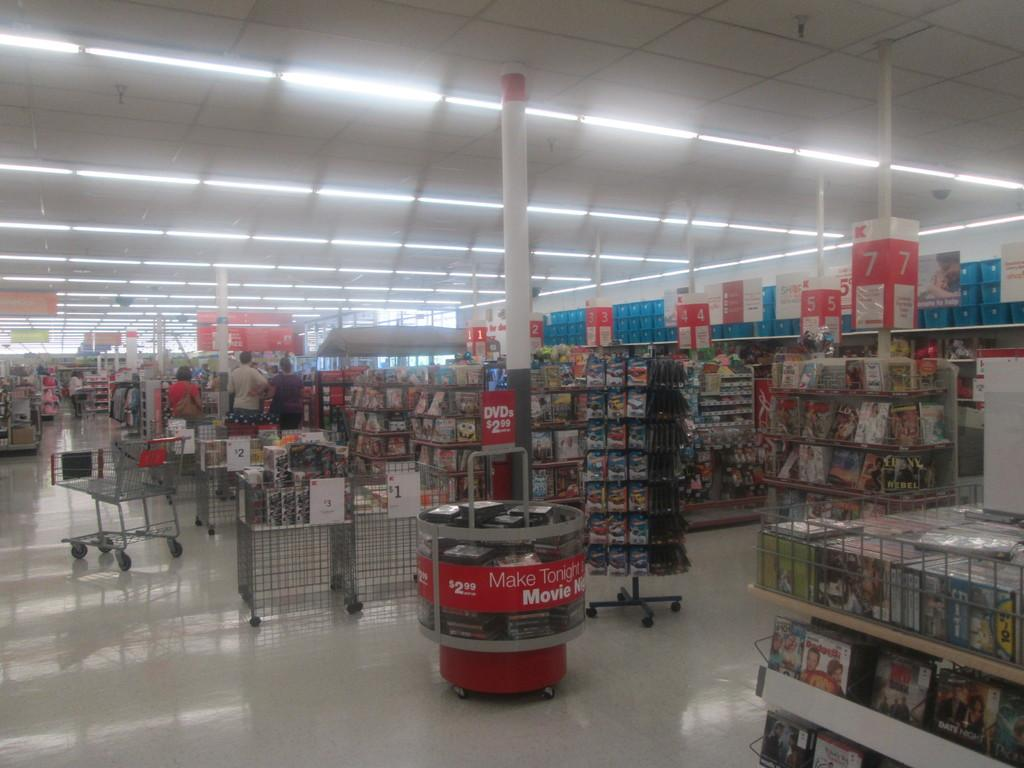<image>
Create a compact narrative representing the image presented. the inside of a store with a display reading "make tonight movie night" 